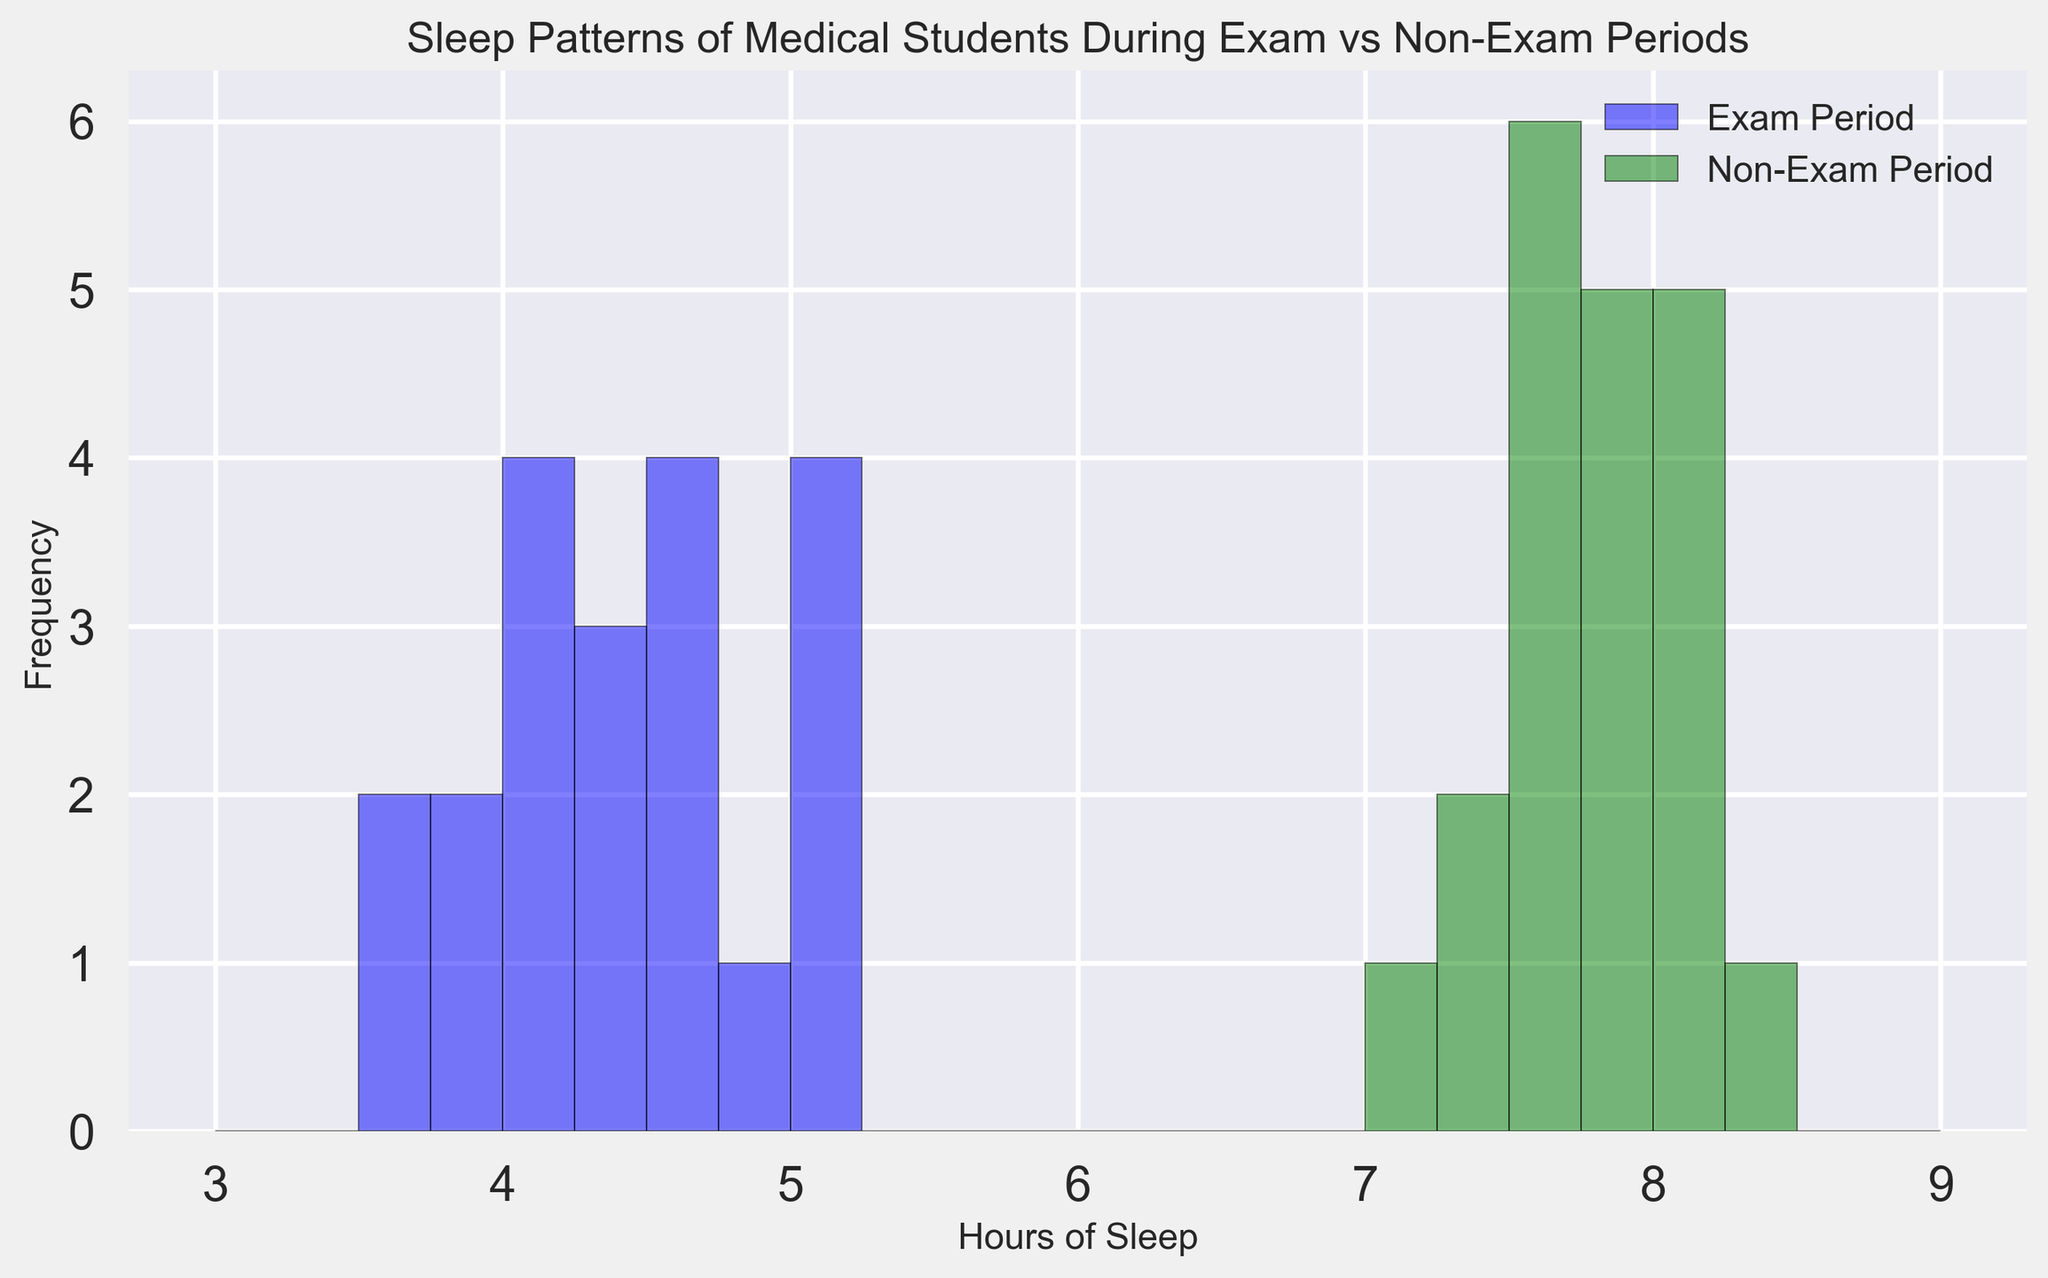Which period shows a higher frequency of lower hours of sleep? By observing the histogram bars, we can compare the height of the bars representing the exam and non-exam periods. The higher bars in the lower hours of sleep range (such as 3.5 to 5 hours) are for the exam period.
Answer: Exam period Which period has a more frequent sleep range of 7.5 to 8.5 hours? Looking at the histogram bars within the sleep range of 7.5 to 8.5 hours, the green bars (representing the non-exam period) are consistently higher in this range.
Answer: Non-exam period How much more frequent is 4 hours of sleep during exams compared to non-exams? By comparing the heights of the bars at the 4-hour mark, the bar for the exam period (blue) is significantly higher than that for the non-exam period (green), indicating higher frequency.
Answer: More frequent by 4 bars height What's the difference in the median hours of sleep between the exam and non-exam periods? We need to arrange the hours of sleep data for both periods and find the median. For exam: (3.5, 3.7, 3.8, 3.9, 4.0, 4.0, 4.1, 4.2, 4.3, 4.3, 4.4, 4.5, 4.5, 4.6, 4.7, 4.8, 5.0, 5.0, 5.1, 5.2) -> Median: 4.4. For non-exam: (7.2, 7.3, 7.4, 7.5, 7.5, 7.6, 7.6, 7.7, 7.7, 7.8, 7.8, 7.8, 7.9, 7.9, 8.0, 8.0, 8.1, 8.1, 8.2, 8.3) -> Median: 7.8. Difference: 7.8 - 4.4 = 3.4 hours.
Answer: 3.4 hours Between 4 and 5 hours of sleep, which period has more consistent sleep patterns? By observing the height and distribution of histogram bars between 4 and 5 hours of sleep, the bars for the exam period (blue) are taller and closer in height, indicating more consistency in sleep patterns.
Answer: Exam period Which period exhibits more variation in hours of sleep? Variation can be visually estimated by the spread and height of the bars. The non-exam period shows a wider spread of sleep hours (7 to 8.5) while the exam period is more constrained (3.5 to 5.2).
Answer: Non-exam period 